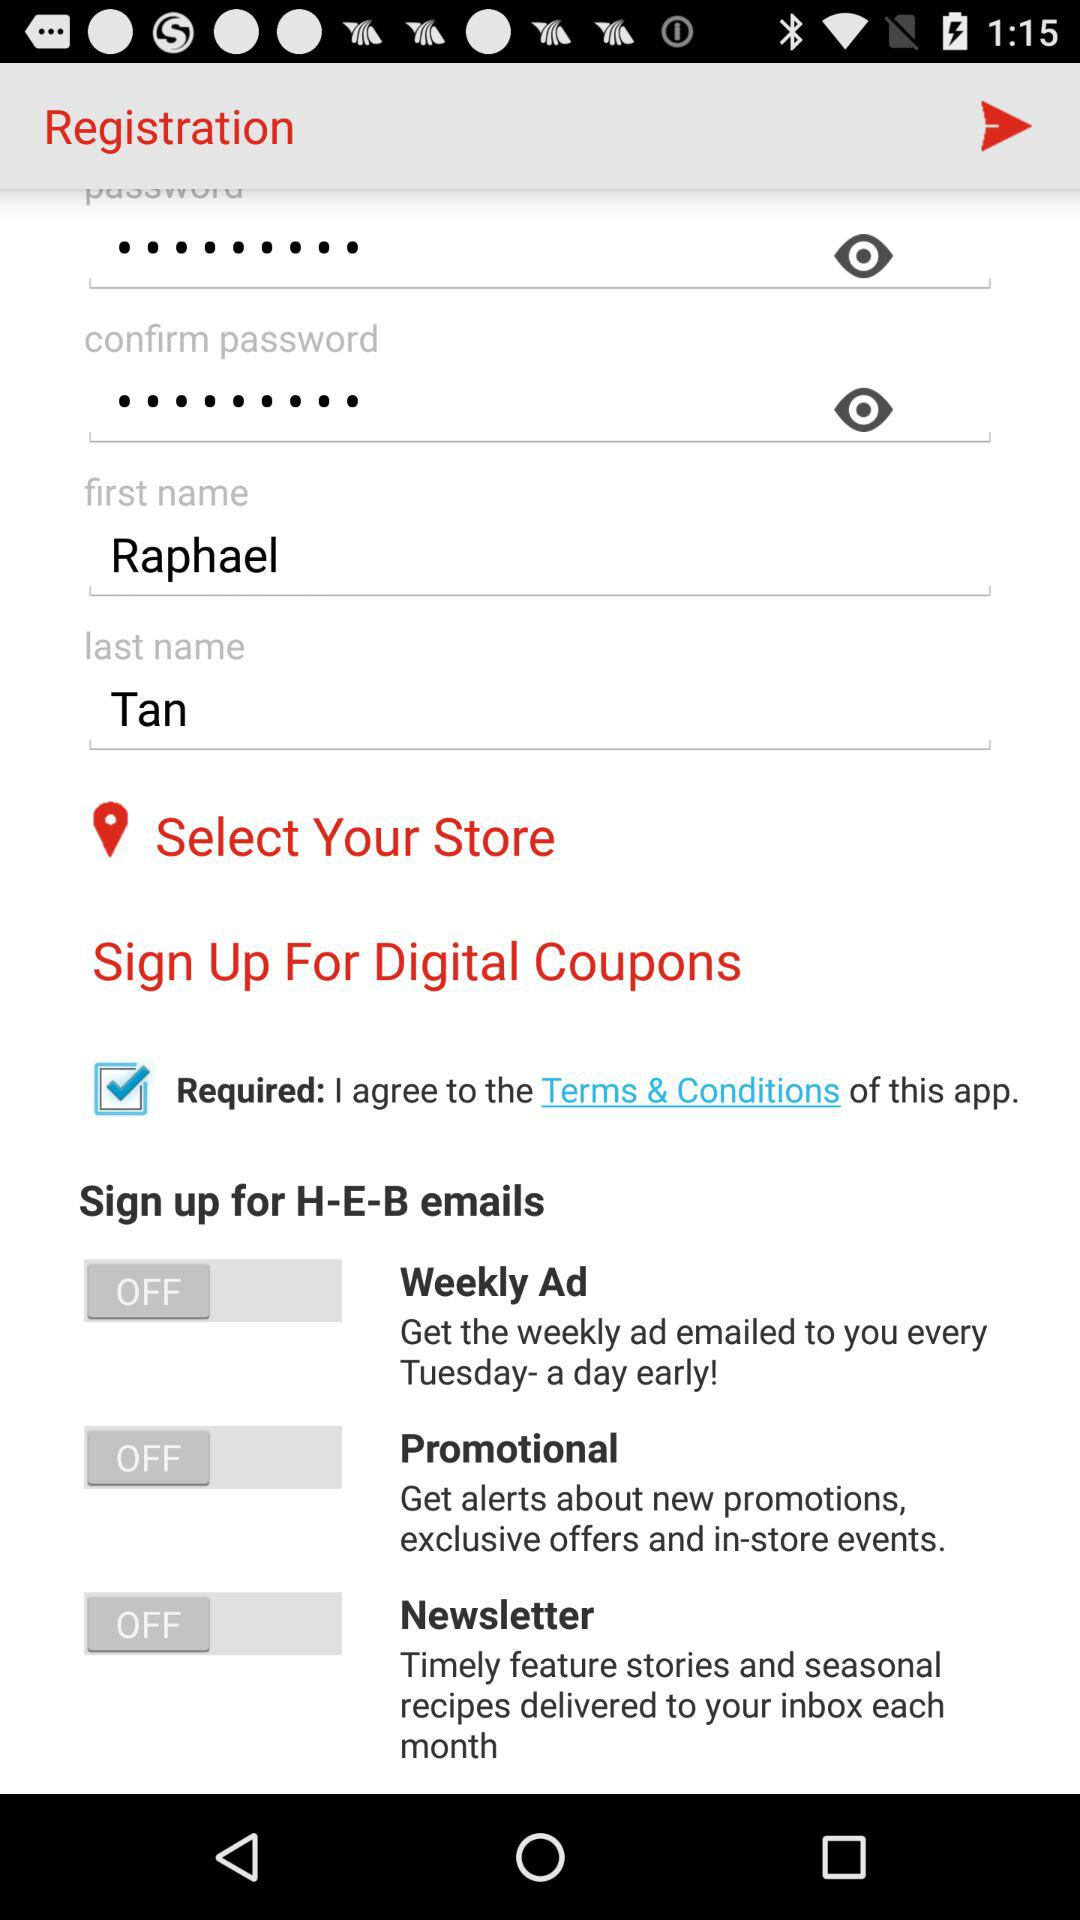What is the status of the "Weekly Ad"? The status is "off". 